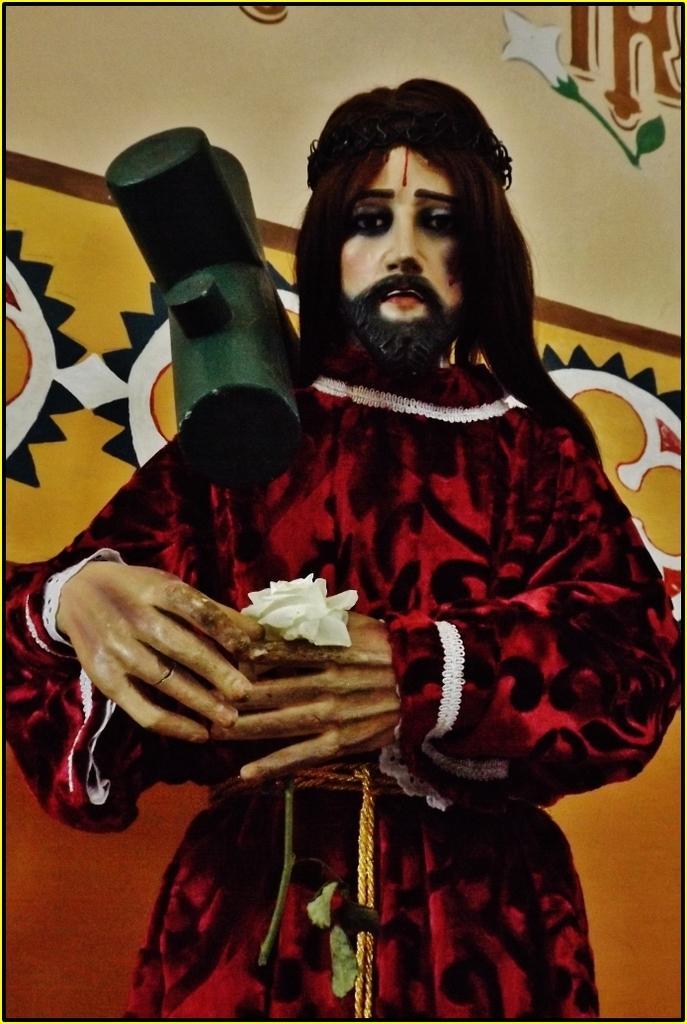Describe this image in one or two sentences. In this image we can see statue of a person holding a flower with stem. Also there is a cross on the shoulder. In the back there is a wall with painting. 